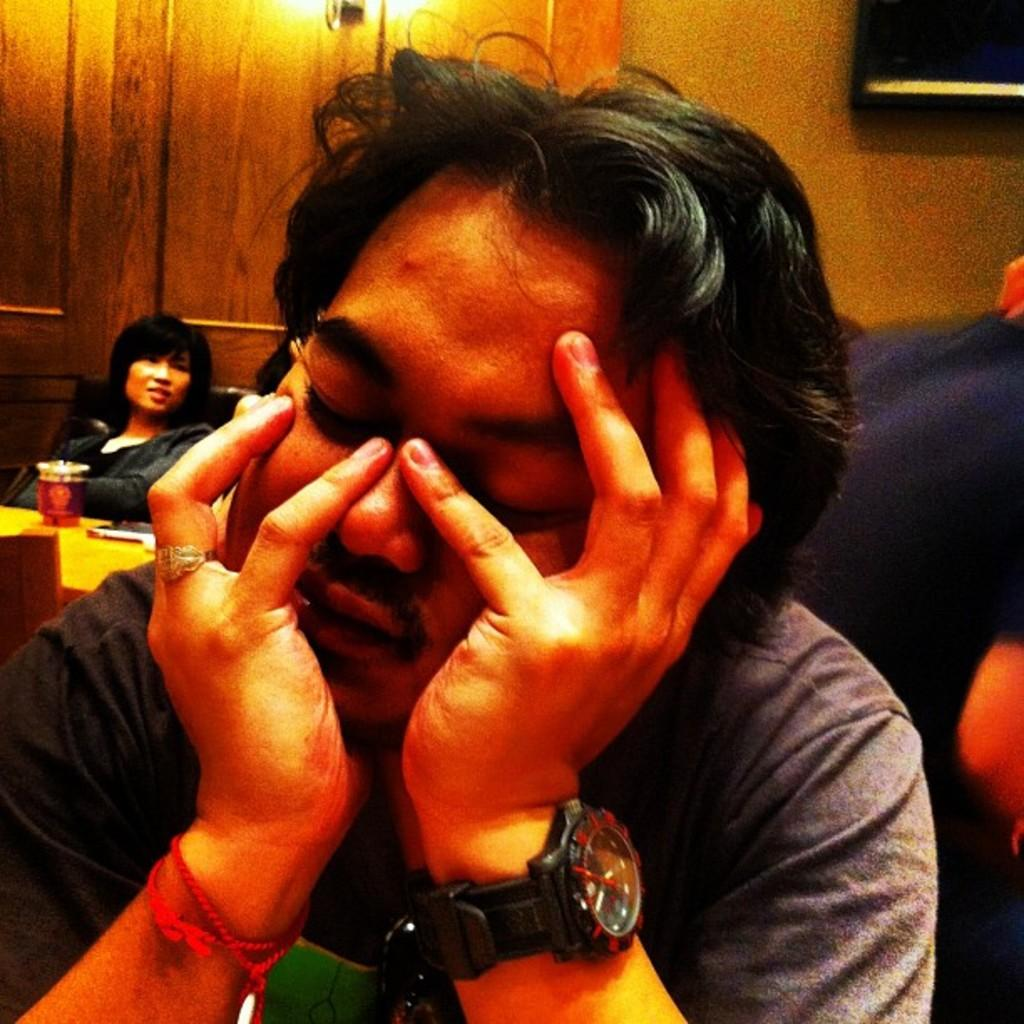What is the main subject in the foreground of the image? There is a person in the foreground of the image. What accessory is the person in the foreground wearing? The person in the foreground is wearing a watch. What is happening in the background of the image? There is a person sitting in the background of the image. What object can be seen on a table in the background of the image? There is a glass on a table in the background of the image. What type of flame can be seen coming from the watch in the image? There is no flame coming from the watch in the image; it is a regular watch. 